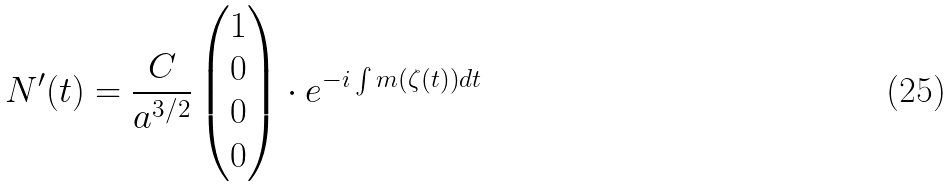Convert formula to latex. <formula><loc_0><loc_0><loc_500><loc_500>N ^ { \prime } ( t ) = \frac { C } { a ^ { 3 / 2 } } \begin{pmatrix} 1 \\ 0 \\ 0 \\ 0 \end{pmatrix} \cdot e ^ { - i \int m \left ( \zeta ( t ) \right ) d t }</formula> 